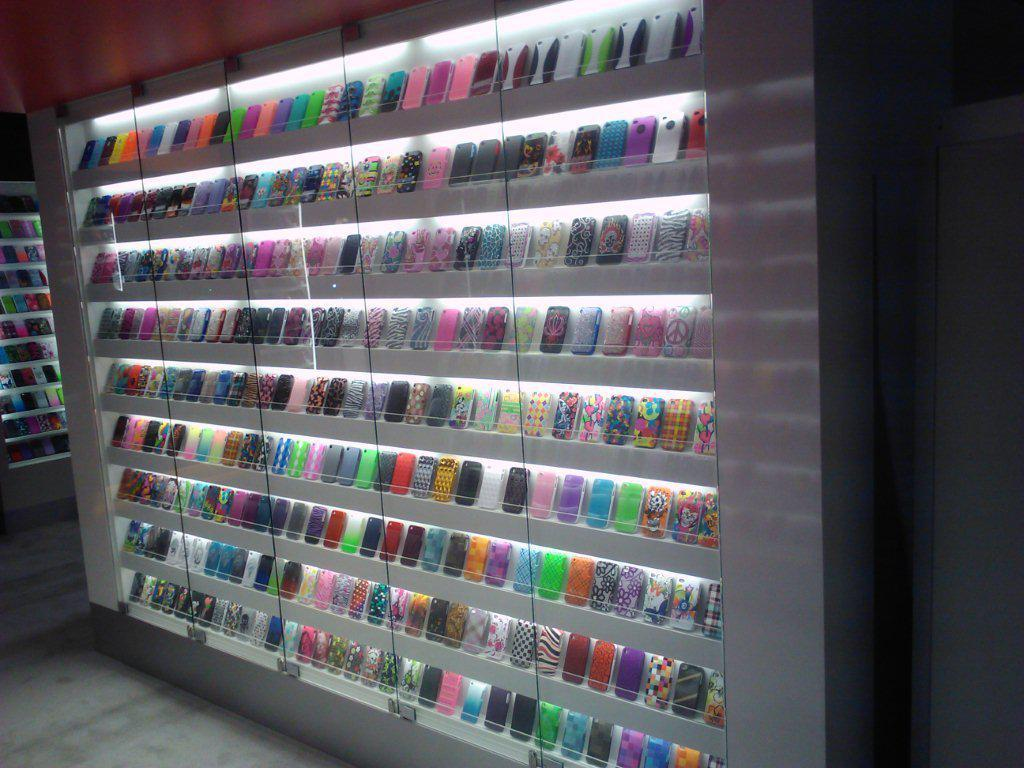What type of items are displayed in the image? There are colorful mobile phone case covers in the image. How are the case covers arranged? The case covers are arranged in a rack. What can be seen behind the rack? There are glass doors in the image. Is there any entrance or exit in the image? Yes, there is a door in the image. What kind of guide is present in the image to help customers choose the right case cover? There is no guide present in the image to help customers choose the right case cover; the image only shows the arrangement of the case covers in a rack. 